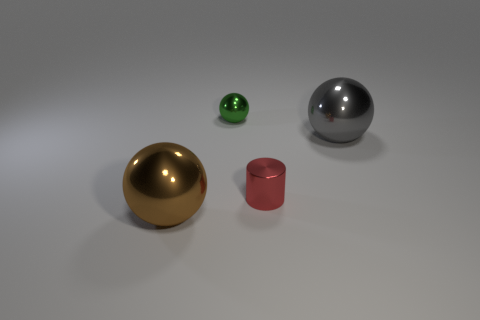Subtract all big spheres. How many spheres are left? 1 Add 4 green metal objects. How many objects exist? 8 Subtract 1 balls. How many balls are left? 2 Subtract all cylinders. How many objects are left? 3 Subtract all red balls. Subtract all brown blocks. How many balls are left? 3 Add 1 yellow metallic cubes. How many yellow metallic cubes exist? 1 Subtract 0 cyan blocks. How many objects are left? 4 Subtract all red cylinders. Subtract all big gray metal balls. How many objects are left? 2 Add 4 brown balls. How many brown balls are left? 5 